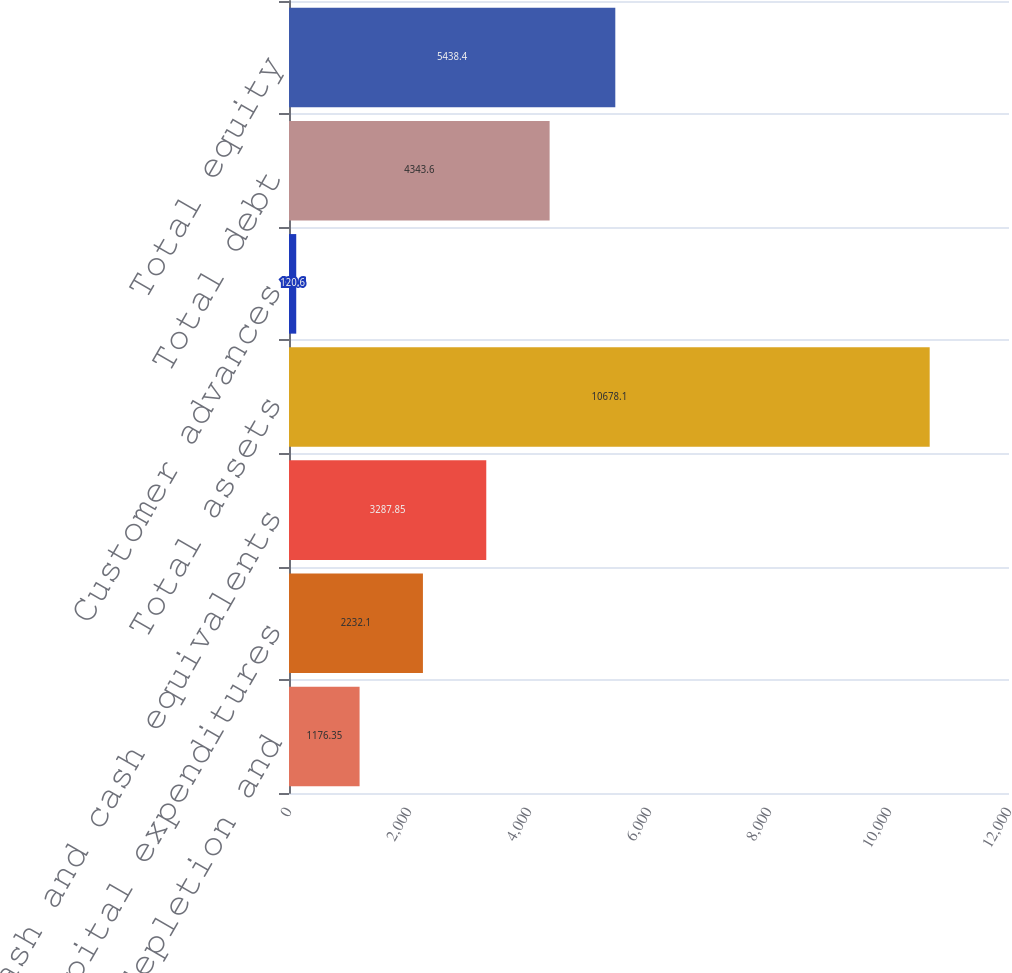Convert chart to OTSL. <chart><loc_0><loc_0><loc_500><loc_500><bar_chart><fcel>Depreciation depletion and<fcel>Capital expenditures<fcel>Cash and cash equivalents<fcel>Total assets<fcel>Customer advances<fcel>Total debt<fcel>Total equity<nl><fcel>1176.35<fcel>2232.1<fcel>3287.85<fcel>10678.1<fcel>120.6<fcel>4343.6<fcel>5438.4<nl></chart> 